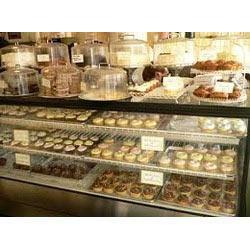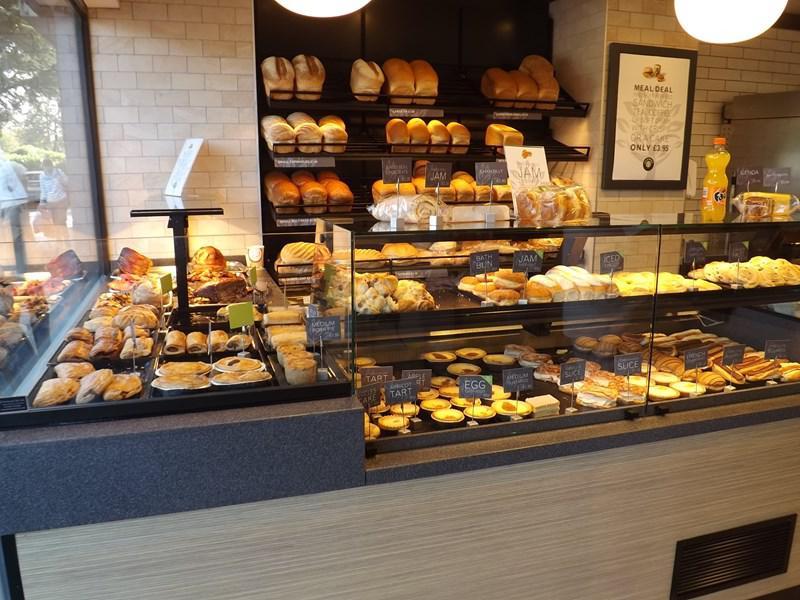The first image is the image on the left, the second image is the image on the right. Evaluate the accuracy of this statement regarding the images: "There are baked goods in baskets in one of the images.". Is it true? Answer yes or no. No. 